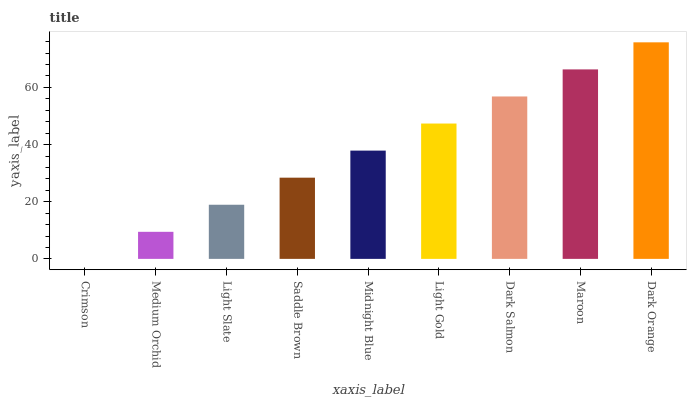Is Crimson the minimum?
Answer yes or no. Yes. Is Dark Orange the maximum?
Answer yes or no. Yes. Is Medium Orchid the minimum?
Answer yes or no. No. Is Medium Orchid the maximum?
Answer yes or no. No. Is Medium Orchid greater than Crimson?
Answer yes or no. Yes. Is Crimson less than Medium Orchid?
Answer yes or no. Yes. Is Crimson greater than Medium Orchid?
Answer yes or no. No. Is Medium Orchid less than Crimson?
Answer yes or no. No. Is Midnight Blue the high median?
Answer yes or no. Yes. Is Midnight Blue the low median?
Answer yes or no. Yes. Is Light Gold the high median?
Answer yes or no. No. Is Light Gold the low median?
Answer yes or no. No. 